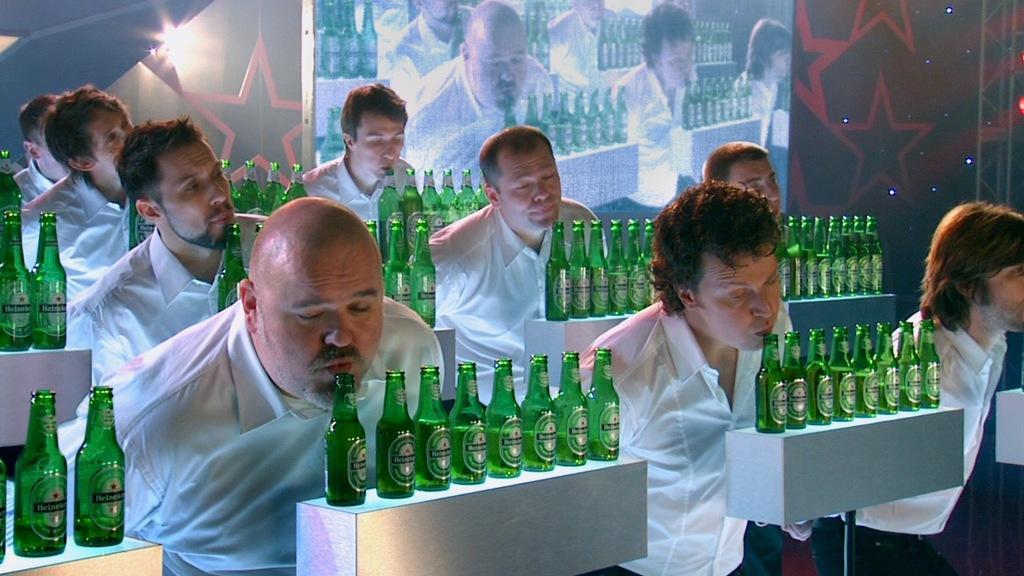How would you summarize this image in a sentence or two? This picture is of inside. On the right corner there is a man wearing white color shirt and standing. In the center there is a table on the top of which many number of bottles are placed and we can see the group of people wearing white color shirt and standing. In the background we can see a wall and a digital screen and also the light. 